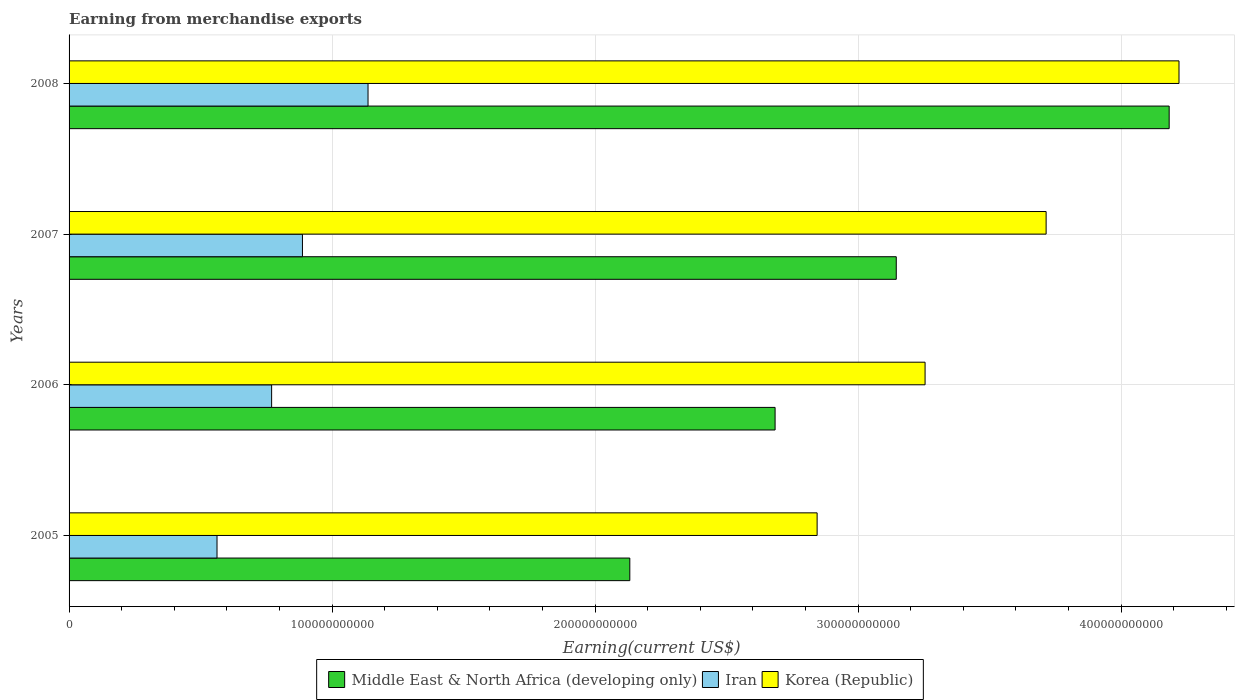How many different coloured bars are there?
Give a very brief answer. 3. How many groups of bars are there?
Your response must be concise. 4. Are the number of bars per tick equal to the number of legend labels?
Keep it short and to the point. Yes. How many bars are there on the 4th tick from the bottom?
Your answer should be compact. 3. What is the label of the 2nd group of bars from the top?
Your answer should be compact. 2007. In how many cases, is the number of bars for a given year not equal to the number of legend labels?
Provide a succinct answer. 0. What is the amount earned from merchandise exports in Middle East & North Africa (developing only) in 2005?
Your answer should be very brief. 2.13e+11. Across all years, what is the maximum amount earned from merchandise exports in Iran?
Your answer should be very brief. 1.14e+11. Across all years, what is the minimum amount earned from merchandise exports in Iran?
Keep it short and to the point. 5.63e+1. In which year was the amount earned from merchandise exports in Iran maximum?
Provide a succinct answer. 2008. In which year was the amount earned from merchandise exports in Korea (Republic) minimum?
Your response must be concise. 2005. What is the total amount earned from merchandise exports in Iran in the graph?
Provide a short and direct response. 3.36e+11. What is the difference between the amount earned from merchandise exports in Iran in 2005 and that in 2006?
Offer a very short reply. -2.08e+1. What is the difference between the amount earned from merchandise exports in Iran in 2005 and the amount earned from merchandise exports in Korea (Republic) in 2007?
Offer a terse response. -3.15e+11. What is the average amount earned from merchandise exports in Korea (Republic) per year?
Provide a short and direct response. 3.51e+11. In the year 2007, what is the difference between the amount earned from merchandise exports in Korea (Republic) and amount earned from merchandise exports in Iran?
Give a very brief answer. 2.83e+11. In how many years, is the amount earned from merchandise exports in Iran greater than 220000000000 US$?
Offer a very short reply. 0. What is the ratio of the amount earned from merchandise exports in Iran in 2005 to that in 2008?
Provide a short and direct response. 0.49. Is the difference between the amount earned from merchandise exports in Korea (Republic) in 2006 and 2007 greater than the difference between the amount earned from merchandise exports in Iran in 2006 and 2007?
Offer a very short reply. No. What is the difference between the highest and the second highest amount earned from merchandise exports in Middle East & North Africa (developing only)?
Provide a short and direct response. 1.04e+11. What is the difference between the highest and the lowest amount earned from merchandise exports in Middle East & North Africa (developing only)?
Keep it short and to the point. 2.05e+11. In how many years, is the amount earned from merchandise exports in Korea (Republic) greater than the average amount earned from merchandise exports in Korea (Republic) taken over all years?
Ensure brevity in your answer.  2. What does the 2nd bar from the top in 2007 represents?
Provide a short and direct response. Iran. What does the 1st bar from the bottom in 2007 represents?
Your answer should be compact. Middle East & North Africa (developing only). Is it the case that in every year, the sum of the amount earned from merchandise exports in Middle East & North Africa (developing only) and amount earned from merchandise exports in Iran is greater than the amount earned from merchandise exports in Korea (Republic)?
Your answer should be compact. No. How many bars are there?
Ensure brevity in your answer.  12. What is the difference between two consecutive major ticks on the X-axis?
Your response must be concise. 1.00e+11. How many legend labels are there?
Offer a terse response. 3. How are the legend labels stacked?
Ensure brevity in your answer.  Horizontal. What is the title of the graph?
Ensure brevity in your answer.  Earning from merchandise exports. What is the label or title of the X-axis?
Your response must be concise. Earning(current US$). What is the label or title of the Y-axis?
Provide a short and direct response. Years. What is the Earning(current US$) of Middle East & North Africa (developing only) in 2005?
Make the answer very short. 2.13e+11. What is the Earning(current US$) in Iran in 2005?
Provide a short and direct response. 5.63e+1. What is the Earning(current US$) in Korea (Republic) in 2005?
Offer a very short reply. 2.84e+11. What is the Earning(current US$) of Middle East & North Africa (developing only) in 2006?
Provide a short and direct response. 2.68e+11. What is the Earning(current US$) in Iran in 2006?
Keep it short and to the point. 7.70e+1. What is the Earning(current US$) of Korea (Republic) in 2006?
Your answer should be very brief. 3.25e+11. What is the Earning(current US$) of Middle East & North Africa (developing only) in 2007?
Ensure brevity in your answer.  3.15e+11. What is the Earning(current US$) in Iran in 2007?
Give a very brief answer. 8.87e+1. What is the Earning(current US$) of Korea (Republic) in 2007?
Your response must be concise. 3.71e+11. What is the Earning(current US$) in Middle East & North Africa (developing only) in 2008?
Your answer should be compact. 4.18e+11. What is the Earning(current US$) in Iran in 2008?
Provide a short and direct response. 1.14e+11. What is the Earning(current US$) of Korea (Republic) in 2008?
Make the answer very short. 4.22e+11. Across all years, what is the maximum Earning(current US$) of Middle East & North Africa (developing only)?
Your answer should be very brief. 4.18e+11. Across all years, what is the maximum Earning(current US$) of Iran?
Provide a short and direct response. 1.14e+11. Across all years, what is the maximum Earning(current US$) in Korea (Republic)?
Give a very brief answer. 4.22e+11. Across all years, what is the minimum Earning(current US$) of Middle East & North Africa (developing only)?
Provide a succinct answer. 2.13e+11. Across all years, what is the minimum Earning(current US$) in Iran?
Provide a succinct answer. 5.63e+1. Across all years, what is the minimum Earning(current US$) in Korea (Republic)?
Ensure brevity in your answer.  2.84e+11. What is the total Earning(current US$) in Middle East & North Africa (developing only) in the graph?
Make the answer very short. 1.21e+12. What is the total Earning(current US$) in Iran in the graph?
Give a very brief answer. 3.36e+11. What is the total Earning(current US$) in Korea (Republic) in the graph?
Your answer should be very brief. 1.40e+12. What is the difference between the Earning(current US$) of Middle East & North Africa (developing only) in 2005 and that in 2006?
Your answer should be very brief. -5.52e+1. What is the difference between the Earning(current US$) in Iran in 2005 and that in 2006?
Give a very brief answer. -2.08e+1. What is the difference between the Earning(current US$) in Korea (Republic) in 2005 and that in 2006?
Keep it short and to the point. -4.10e+1. What is the difference between the Earning(current US$) in Middle East & North Africa (developing only) in 2005 and that in 2007?
Make the answer very short. -1.01e+11. What is the difference between the Earning(current US$) in Iran in 2005 and that in 2007?
Offer a very short reply. -3.25e+1. What is the difference between the Earning(current US$) in Korea (Republic) in 2005 and that in 2007?
Offer a terse response. -8.71e+1. What is the difference between the Earning(current US$) in Middle East & North Africa (developing only) in 2005 and that in 2008?
Your answer should be compact. -2.05e+11. What is the difference between the Earning(current US$) of Iran in 2005 and that in 2008?
Offer a terse response. -5.74e+1. What is the difference between the Earning(current US$) in Korea (Republic) in 2005 and that in 2008?
Keep it short and to the point. -1.38e+11. What is the difference between the Earning(current US$) in Middle East & North Africa (developing only) in 2006 and that in 2007?
Give a very brief answer. -4.61e+1. What is the difference between the Earning(current US$) of Iran in 2006 and that in 2007?
Make the answer very short. -1.17e+1. What is the difference between the Earning(current US$) of Korea (Republic) in 2006 and that in 2007?
Provide a succinct answer. -4.60e+1. What is the difference between the Earning(current US$) in Middle East & North Africa (developing only) in 2006 and that in 2008?
Your answer should be compact. -1.50e+11. What is the difference between the Earning(current US$) of Iran in 2006 and that in 2008?
Offer a very short reply. -3.67e+1. What is the difference between the Earning(current US$) in Korea (Republic) in 2006 and that in 2008?
Your answer should be compact. -9.65e+1. What is the difference between the Earning(current US$) of Middle East & North Africa (developing only) in 2007 and that in 2008?
Offer a terse response. -1.04e+11. What is the difference between the Earning(current US$) of Iran in 2007 and that in 2008?
Offer a terse response. -2.49e+1. What is the difference between the Earning(current US$) in Korea (Republic) in 2007 and that in 2008?
Provide a short and direct response. -5.05e+1. What is the difference between the Earning(current US$) of Middle East & North Africa (developing only) in 2005 and the Earning(current US$) of Iran in 2006?
Provide a succinct answer. 1.36e+11. What is the difference between the Earning(current US$) in Middle East & North Africa (developing only) in 2005 and the Earning(current US$) in Korea (Republic) in 2006?
Your answer should be very brief. -1.12e+11. What is the difference between the Earning(current US$) in Iran in 2005 and the Earning(current US$) in Korea (Republic) in 2006?
Keep it short and to the point. -2.69e+11. What is the difference between the Earning(current US$) in Middle East & North Africa (developing only) in 2005 and the Earning(current US$) in Iran in 2007?
Your response must be concise. 1.24e+11. What is the difference between the Earning(current US$) of Middle East & North Africa (developing only) in 2005 and the Earning(current US$) of Korea (Republic) in 2007?
Provide a succinct answer. -1.58e+11. What is the difference between the Earning(current US$) of Iran in 2005 and the Earning(current US$) of Korea (Republic) in 2007?
Make the answer very short. -3.15e+11. What is the difference between the Earning(current US$) in Middle East & North Africa (developing only) in 2005 and the Earning(current US$) in Iran in 2008?
Offer a very short reply. 9.95e+1. What is the difference between the Earning(current US$) of Middle East & North Africa (developing only) in 2005 and the Earning(current US$) of Korea (Republic) in 2008?
Your answer should be compact. -2.09e+11. What is the difference between the Earning(current US$) of Iran in 2005 and the Earning(current US$) of Korea (Republic) in 2008?
Your answer should be compact. -3.66e+11. What is the difference between the Earning(current US$) in Middle East & North Africa (developing only) in 2006 and the Earning(current US$) in Iran in 2007?
Provide a short and direct response. 1.80e+11. What is the difference between the Earning(current US$) in Middle East & North Africa (developing only) in 2006 and the Earning(current US$) in Korea (Republic) in 2007?
Your answer should be very brief. -1.03e+11. What is the difference between the Earning(current US$) in Iran in 2006 and the Earning(current US$) in Korea (Republic) in 2007?
Give a very brief answer. -2.94e+11. What is the difference between the Earning(current US$) of Middle East & North Africa (developing only) in 2006 and the Earning(current US$) of Iran in 2008?
Offer a terse response. 1.55e+11. What is the difference between the Earning(current US$) in Middle East & North Africa (developing only) in 2006 and the Earning(current US$) in Korea (Republic) in 2008?
Give a very brief answer. -1.54e+11. What is the difference between the Earning(current US$) in Iran in 2006 and the Earning(current US$) in Korea (Republic) in 2008?
Your response must be concise. -3.45e+11. What is the difference between the Earning(current US$) in Middle East & North Africa (developing only) in 2007 and the Earning(current US$) in Iran in 2008?
Ensure brevity in your answer.  2.01e+11. What is the difference between the Earning(current US$) in Middle East & North Africa (developing only) in 2007 and the Earning(current US$) in Korea (Republic) in 2008?
Make the answer very short. -1.07e+11. What is the difference between the Earning(current US$) in Iran in 2007 and the Earning(current US$) in Korea (Republic) in 2008?
Make the answer very short. -3.33e+11. What is the average Earning(current US$) in Middle East & North Africa (developing only) per year?
Make the answer very short. 3.04e+11. What is the average Earning(current US$) in Iran per year?
Your answer should be compact. 8.39e+1. What is the average Earning(current US$) of Korea (Republic) per year?
Give a very brief answer. 3.51e+11. In the year 2005, what is the difference between the Earning(current US$) in Middle East & North Africa (developing only) and Earning(current US$) in Iran?
Offer a very short reply. 1.57e+11. In the year 2005, what is the difference between the Earning(current US$) in Middle East & North Africa (developing only) and Earning(current US$) in Korea (Republic)?
Keep it short and to the point. -7.12e+1. In the year 2005, what is the difference between the Earning(current US$) of Iran and Earning(current US$) of Korea (Republic)?
Provide a short and direct response. -2.28e+11. In the year 2006, what is the difference between the Earning(current US$) in Middle East & North Africa (developing only) and Earning(current US$) in Iran?
Ensure brevity in your answer.  1.91e+11. In the year 2006, what is the difference between the Earning(current US$) in Middle East & North Africa (developing only) and Earning(current US$) in Korea (Republic)?
Offer a very short reply. -5.70e+1. In the year 2006, what is the difference between the Earning(current US$) in Iran and Earning(current US$) in Korea (Republic)?
Keep it short and to the point. -2.48e+11. In the year 2007, what is the difference between the Earning(current US$) of Middle East & North Africa (developing only) and Earning(current US$) of Iran?
Make the answer very short. 2.26e+11. In the year 2007, what is the difference between the Earning(current US$) of Middle East & North Africa (developing only) and Earning(current US$) of Korea (Republic)?
Keep it short and to the point. -5.70e+1. In the year 2007, what is the difference between the Earning(current US$) in Iran and Earning(current US$) in Korea (Republic)?
Provide a succinct answer. -2.83e+11. In the year 2008, what is the difference between the Earning(current US$) in Middle East & North Africa (developing only) and Earning(current US$) in Iran?
Offer a terse response. 3.05e+11. In the year 2008, what is the difference between the Earning(current US$) in Middle East & North Africa (developing only) and Earning(current US$) in Korea (Republic)?
Your answer should be very brief. -3.74e+09. In the year 2008, what is the difference between the Earning(current US$) of Iran and Earning(current US$) of Korea (Republic)?
Your answer should be compact. -3.08e+11. What is the ratio of the Earning(current US$) in Middle East & North Africa (developing only) in 2005 to that in 2006?
Ensure brevity in your answer.  0.79. What is the ratio of the Earning(current US$) of Iran in 2005 to that in 2006?
Offer a very short reply. 0.73. What is the ratio of the Earning(current US$) of Korea (Republic) in 2005 to that in 2006?
Offer a terse response. 0.87. What is the ratio of the Earning(current US$) of Middle East & North Africa (developing only) in 2005 to that in 2007?
Give a very brief answer. 0.68. What is the ratio of the Earning(current US$) of Iran in 2005 to that in 2007?
Provide a succinct answer. 0.63. What is the ratio of the Earning(current US$) in Korea (Republic) in 2005 to that in 2007?
Your response must be concise. 0.77. What is the ratio of the Earning(current US$) of Middle East & North Africa (developing only) in 2005 to that in 2008?
Give a very brief answer. 0.51. What is the ratio of the Earning(current US$) in Iran in 2005 to that in 2008?
Your answer should be very brief. 0.49. What is the ratio of the Earning(current US$) in Korea (Republic) in 2005 to that in 2008?
Offer a terse response. 0.67. What is the ratio of the Earning(current US$) in Middle East & North Africa (developing only) in 2006 to that in 2007?
Your response must be concise. 0.85. What is the ratio of the Earning(current US$) in Iran in 2006 to that in 2007?
Make the answer very short. 0.87. What is the ratio of the Earning(current US$) in Korea (Republic) in 2006 to that in 2007?
Provide a succinct answer. 0.88. What is the ratio of the Earning(current US$) of Middle East & North Africa (developing only) in 2006 to that in 2008?
Ensure brevity in your answer.  0.64. What is the ratio of the Earning(current US$) of Iran in 2006 to that in 2008?
Provide a short and direct response. 0.68. What is the ratio of the Earning(current US$) of Korea (Republic) in 2006 to that in 2008?
Ensure brevity in your answer.  0.77. What is the ratio of the Earning(current US$) of Middle East & North Africa (developing only) in 2007 to that in 2008?
Offer a terse response. 0.75. What is the ratio of the Earning(current US$) of Iran in 2007 to that in 2008?
Provide a succinct answer. 0.78. What is the ratio of the Earning(current US$) in Korea (Republic) in 2007 to that in 2008?
Your answer should be very brief. 0.88. What is the difference between the highest and the second highest Earning(current US$) of Middle East & North Africa (developing only)?
Provide a succinct answer. 1.04e+11. What is the difference between the highest and the second highest Earning(current US$) in Iran?
Ensure brevity in your answer.  2.49e+1. What is the difference between the highest and the second highest Earning(current US$) in Korea (Republic)?
Give a very brief answer. 5.05e+1. What is the difference between the highest and the lowest Earning(current US$) in Middle East & North Africa (developing only)?
Your answer should be compact. 2.05e+11. What is the difference between the highest and the lowest Earning(current US$) of Iran?
Your response must be concise. 5.74e+1. What is the difference between the highest and the lowest Earning(current US$) in Korea (Republic)?
Offer a very short reply. 1.38e+11. 